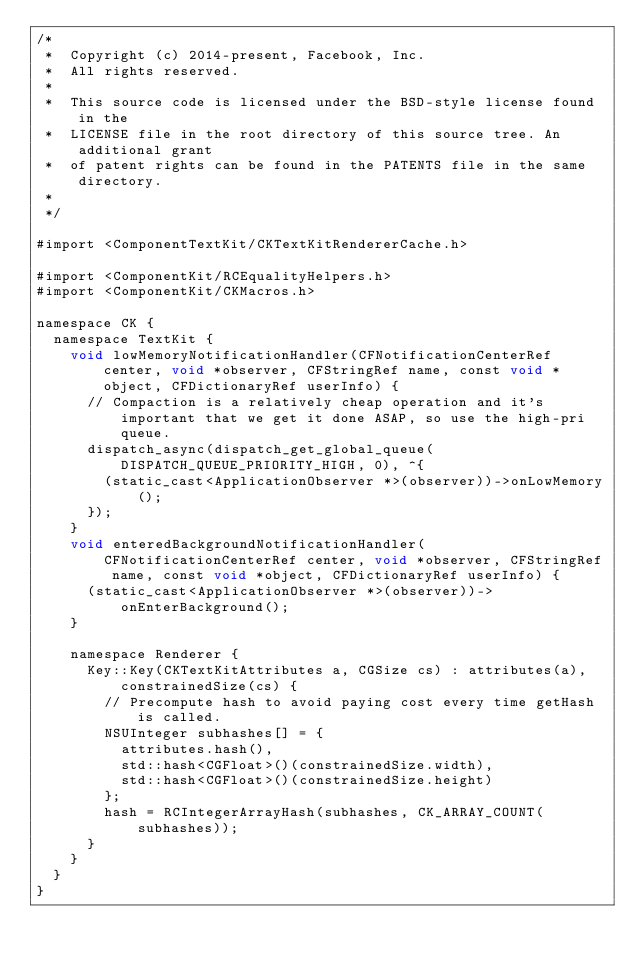<code> <loc_0><loc_0><loc_500><loc_500><_ObjectiveC_>/*
 *  Copyright (c) 2014-present, Facebook, Inc.
 *  All rights reserved.
 *
 *  This source code is licensed under the BSD-style license found in the
 *  LICENSE file in the root directory of this source tree. An additional grant
 *  of patent rights can be found in the PATENTS file in the same directory.
 *
 */

#import <ComponentTextKit/CKTextKitRendererCache.h>

#import <ComponentKit/RCEqualityHelpers.h>
#import <ComponentKit/CKMacros.h>

namespace CK {
  namespace TextKit {
    void lowMemoryNotificationHandler(CFNotificationCenterRef center, void *observer, CFStringRef name, const void *object, CFDictionaryRef userInfo) {
      // Compaction is a relatively cheap operation and it's important that we get it done ASAP, so use the high-pri queue.
      dispatch_async(dispatch_get_global_queue(DISPATCH_QUEUE_PRIORITY_HIGH, 0), ^{
        (static_cast<ApplicationObserver *>(observer))->onLowMemory();
      });
    }
    void enteredBackgroundNotificationHandler(CFNotificationCenterRef center, void *observer, CFStringRef name, const void *object, CFDictionaryRef userInfo) {
      (static_cast<ApplicationObserver *>(observer))->onEnterBackground();
    }

    namespace Renderer {
      Key::Key(CKTextKitAttributes a, CGSize cs) : attributes(a), constrainedSize(cs) {
        // Precompute hash to avoid paying cost every time getHash is called.
        NSUInteger subhashes[] = {
          attributes.hash(),
          std::hash<CGFloat>()(constrainedSize.width),
          std::hash<CGFloat>()(constrainedSize.height)
        };
        hash = RCIntegerArrayHash(subhashes, CK_ARRAY_COUNT(subhashes));
      }
    }
  }
}
</code> 